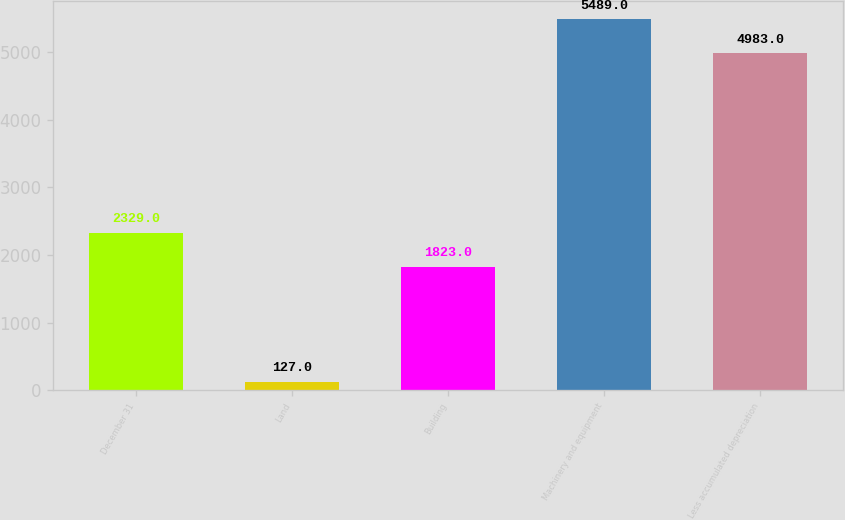<chart> <loc_0><loc_0><loc_500><loc_500><bar_chart><fcel>December 31<fcel>Land<fcel>Building<fcel>Machinery and equipment<fcel>Less accumulated depreciation<nl><fcel>2329<fcel>127<fcel>1823<fcel>5489<fcel>4983<nl></chart> 